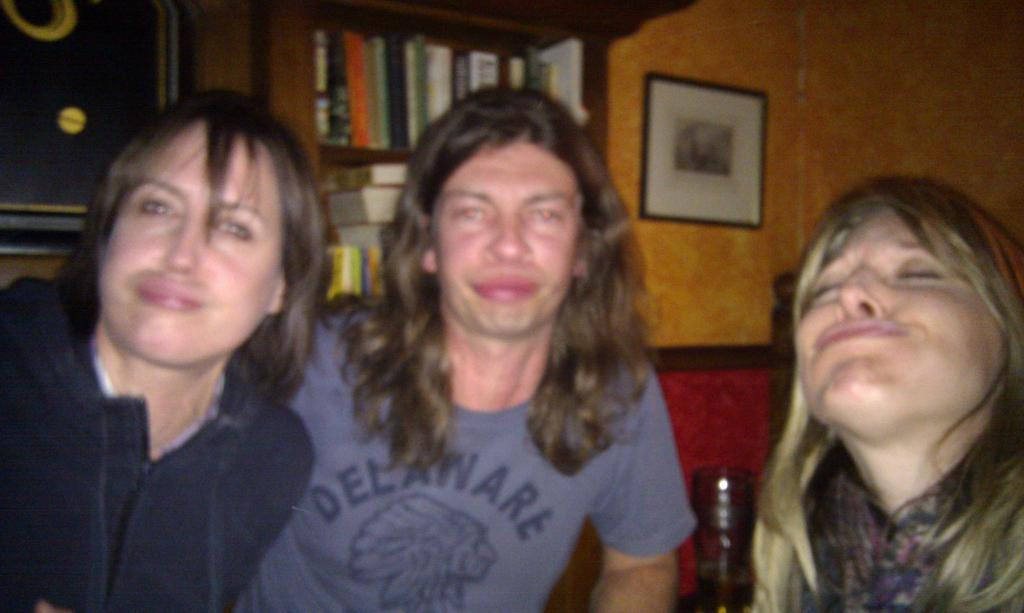How many people are present in the image? There are three people in the image. What can be seen besides the people in the image? There is a bottle, a shelf, a wall, and a photo visible in the image. What is on the shelf in the background? The shelf has books and other objects on it. Can you describe the wall on the right side of the image? The wall has a photo on it. How does the crack in the wall affect the photo on the right side of the image? There is no crack in the wall mentioned in the facts, so it cannot affect the photo. 